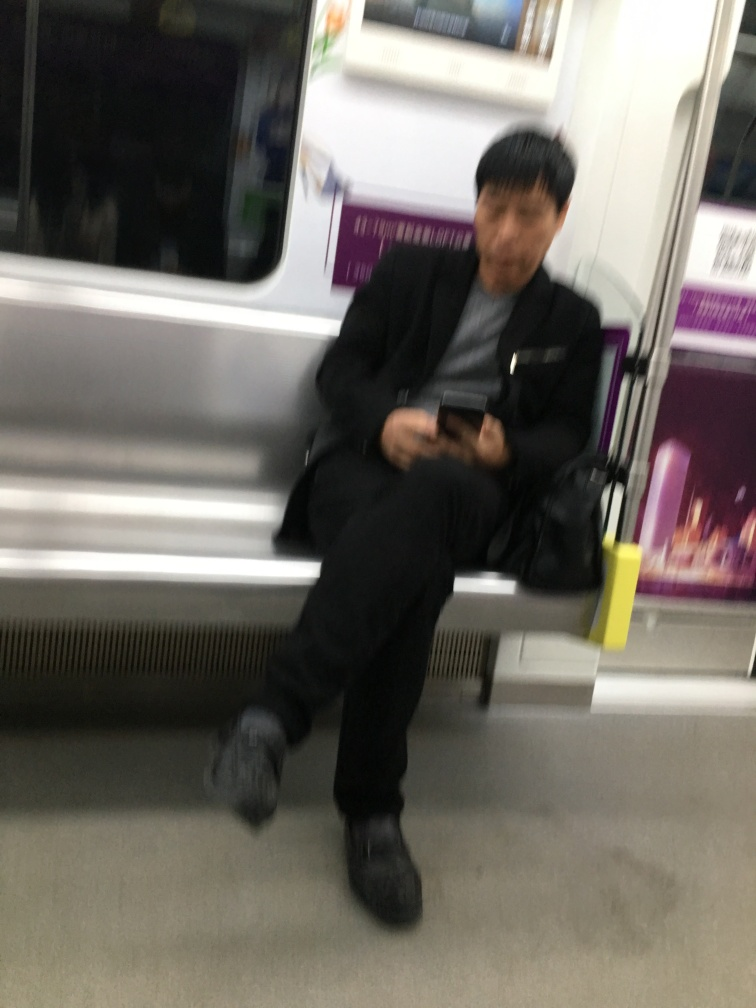What emotional ambiance can you infer from this image? The image projects a sense of solitude or contemplation, as the individual appears to be alone with their thoughts, immersed in what they're doing on their device. The blurriness and quiet setting could also evoke a feeling of motion and transience. 